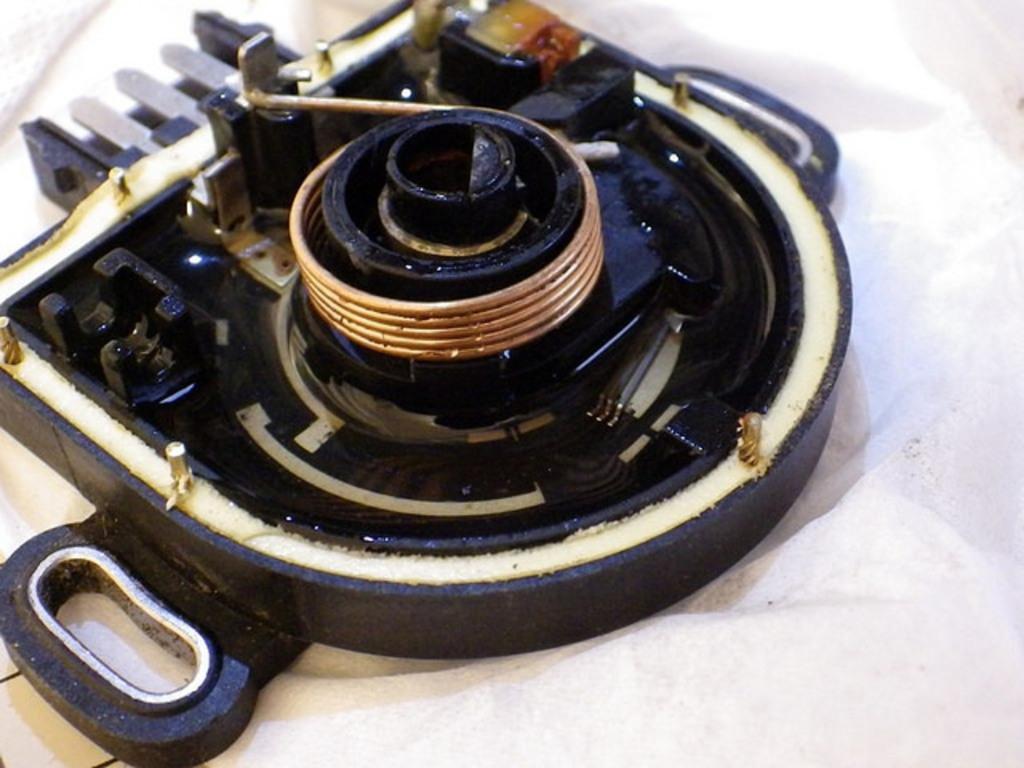Can you describe this image briefly? The picture consists of a tool in which we can see copper winding. On the right there is a white color cloth. 